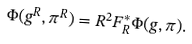<formula> <loc_0><loc_0><loc_500><loc_500>\Phi ( g ^ { R } , \pi ^ { R } ) = R ^ { 2 } F _ { R } ^ { * } \Phi ( g , \pi ) .</formula> 